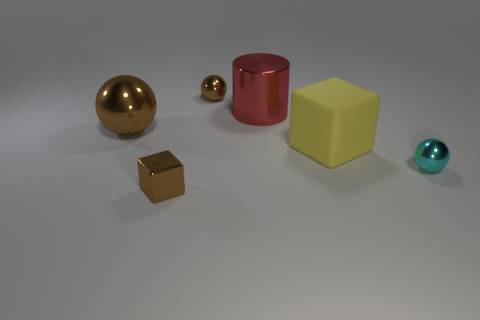How many matte blocks are the same size as the red cylinder?
Provide a short and direct response. 1. There is a small object that is the same shape as the large rubber thing; what is its material?
Provide a succinct answer. Metal. Does the small ball behind the large yellow rubber object have the same color as the tiny metallic ball in front of the big shiny ball?
Your answer should be very brief. No. There is a cyan thing on the right side of the large cylinder; what shape is it?
Provide a succinct answer. Sphere. The small metal block has what color?
Make the answer very short. Brown. The big brown thing that is the same material as the tiny cyan object is what shape?
Your response must be concise. Sphere. There is a cyan shiny object that is on the right side of the rubber thing; does it have the same size as the large red cylinder?
Keep it short and to the point. No. How many objects are either shiny spheres that are on the left side of the cyan thing or brown objects right of the large brown shiny sphere?
Ensure brevity in your answer.  3. Is the color of the tiny sphere behind the big rubber block the same as the big cylinder?
Provide a succinct answer. No. What number of shiny things are cubes or big cylinders?
Keep it short and to the point. 2. 